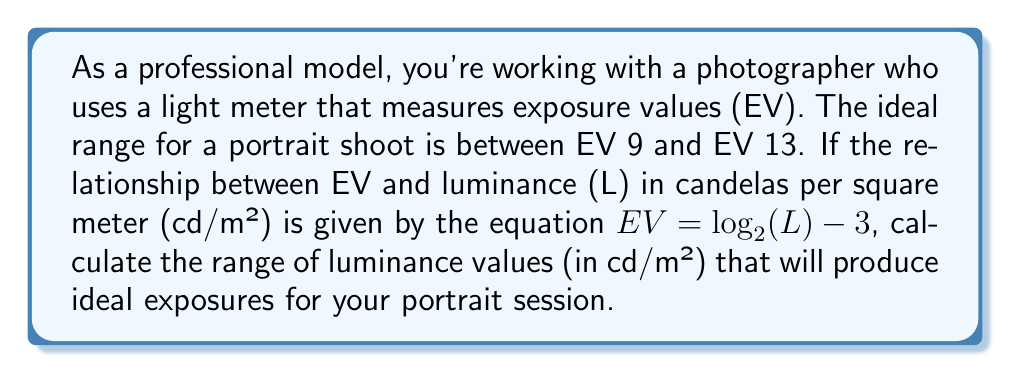Can you answer this question? Let's approach this step-by-step:

1) We are given that the ideal EV range is between 9 and 13.

2) The relationship between EV and luminance (L) is:
   $EV = \log_2(L) - 3$

3) To find the range of L, we need to solve this equation for L:
   $EV + 3 = \log_2(L)$
   $2^{EV + 3} = L$

4) Now, let's calculate the minimum L (when EV = 9):
   $L_{min} = 2^{9 + 3} = 2^{12} = 4096$ cd/m²

5) And the maximum L (when EV = 13):
   $L_{max} = 2^{13 + 3} = 2^{16} = 65536$ cd/m²

Therefore, the range of luminance values for ideal exposures is from 4096 cd/m² to 65536 cd/m².
Answer: $[4096, 65536]$ cd/m² 